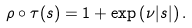<formula> <loc_0><loc_0><loc_500><loc_500>\rho \circ \tau ( s ) = 1 + \exp \left ( \nu | s | \right ) .</formula> 